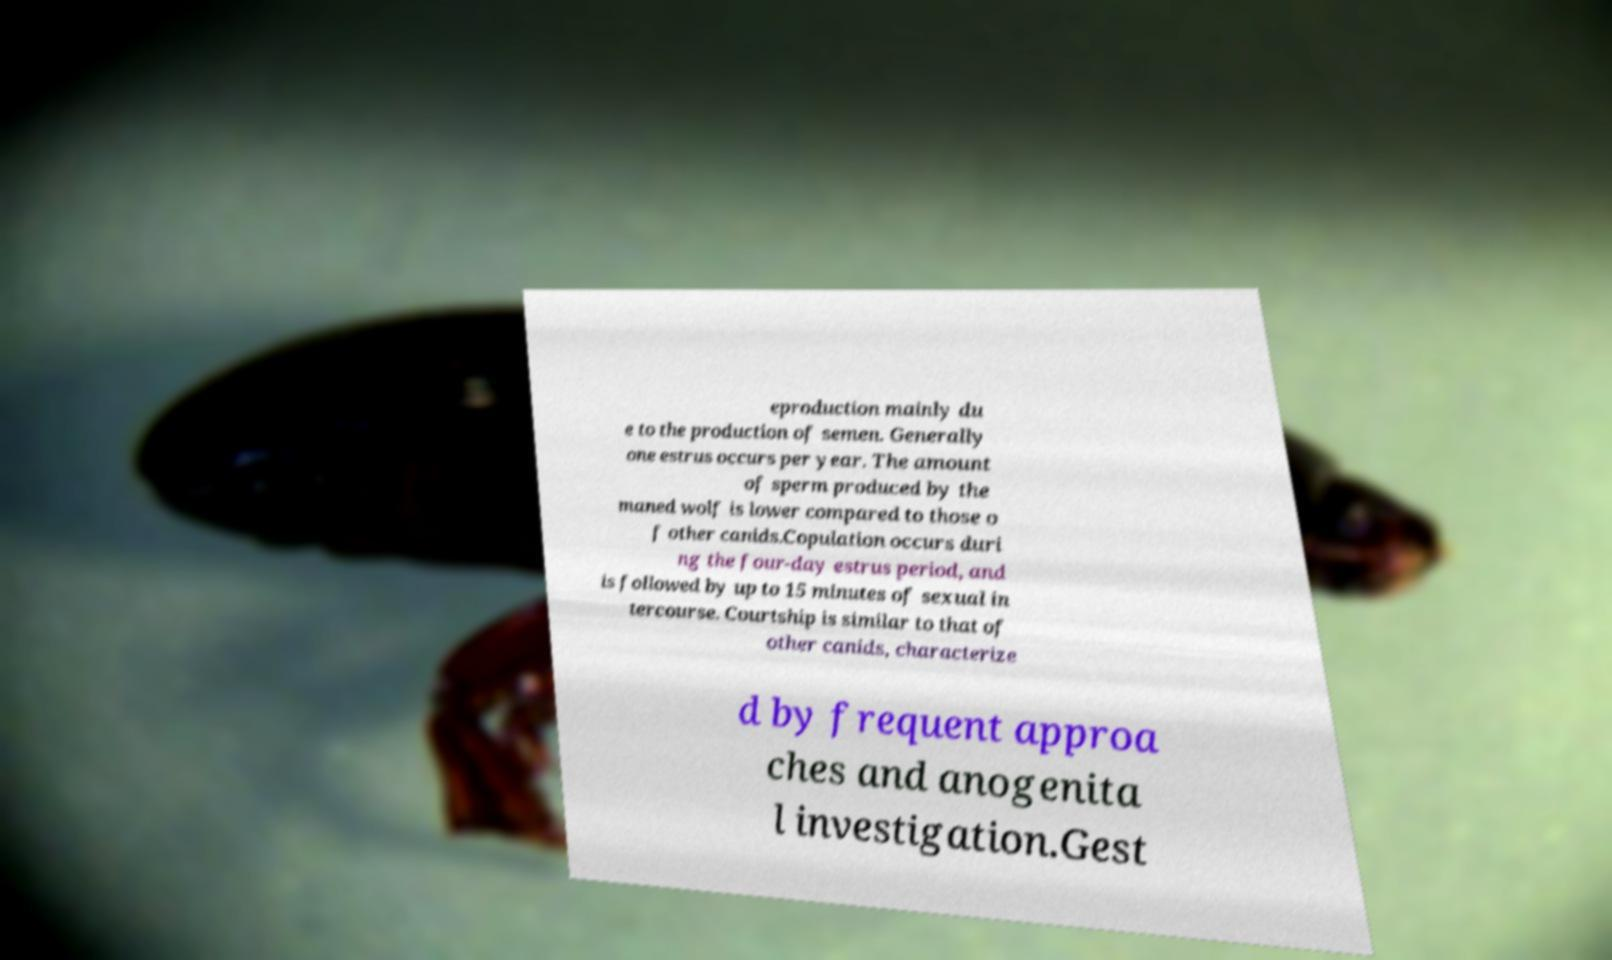Could you assist in decoding the text presented in this image and type it out clearly? eproduction mainly du e to the production of semen. Generally one estrus occurs per year. The amount of sperm produced by the maned wolf is lower compared to those o f other canids.Copulation occurs duri ng the four-day estrus period, and is followed by up to 15 minutes of sexual in tercourse. Courtship is similar to that of other canids, characterize d by frequent approa ches and anogenita l investigation.Gest 